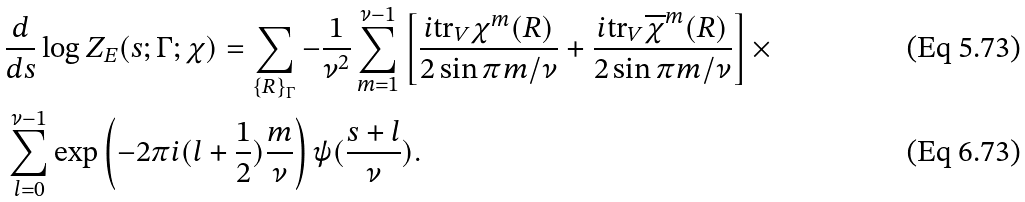<formula> <loc_0><loc_0><loc_500><loc_500>& \frac { d } { d s } \log Z _ { E } ( s ; \Gamma ; \chi ) = \sum _ { \left \{ R \right \} _ { \Gamma } } - \frac { 1 } { \nu ^ { 2 } } \sum _ { m = 1 } ^ { \nu - 1 } \left [ \frac { i \text {tr} _ { V } \chi ^ { m } ( R ) } { 2 \sin \pi m / \nu } + \frac { i \text {tr} _ { V } \overline { \chi } ^ { m } ( R ) } { 2 \sin \pi m / \nu } \right ] \times \\ & \sum _ { l = 0 } ^ { \nu - 1 } \exp \left ( - 2 \pi i ( l + \frac { 1 } { 2 } ) \frac { m } { \nu } \right ) \psi ( \frac { s + l } { \nu } ) .</formula> 